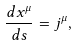Convert formula to latex. <formula><loc_0><loc_0><loc_500><loc_500>\frac { d x ^ { \mu } } { d s } = j ^ { \mu } ,</formula> 